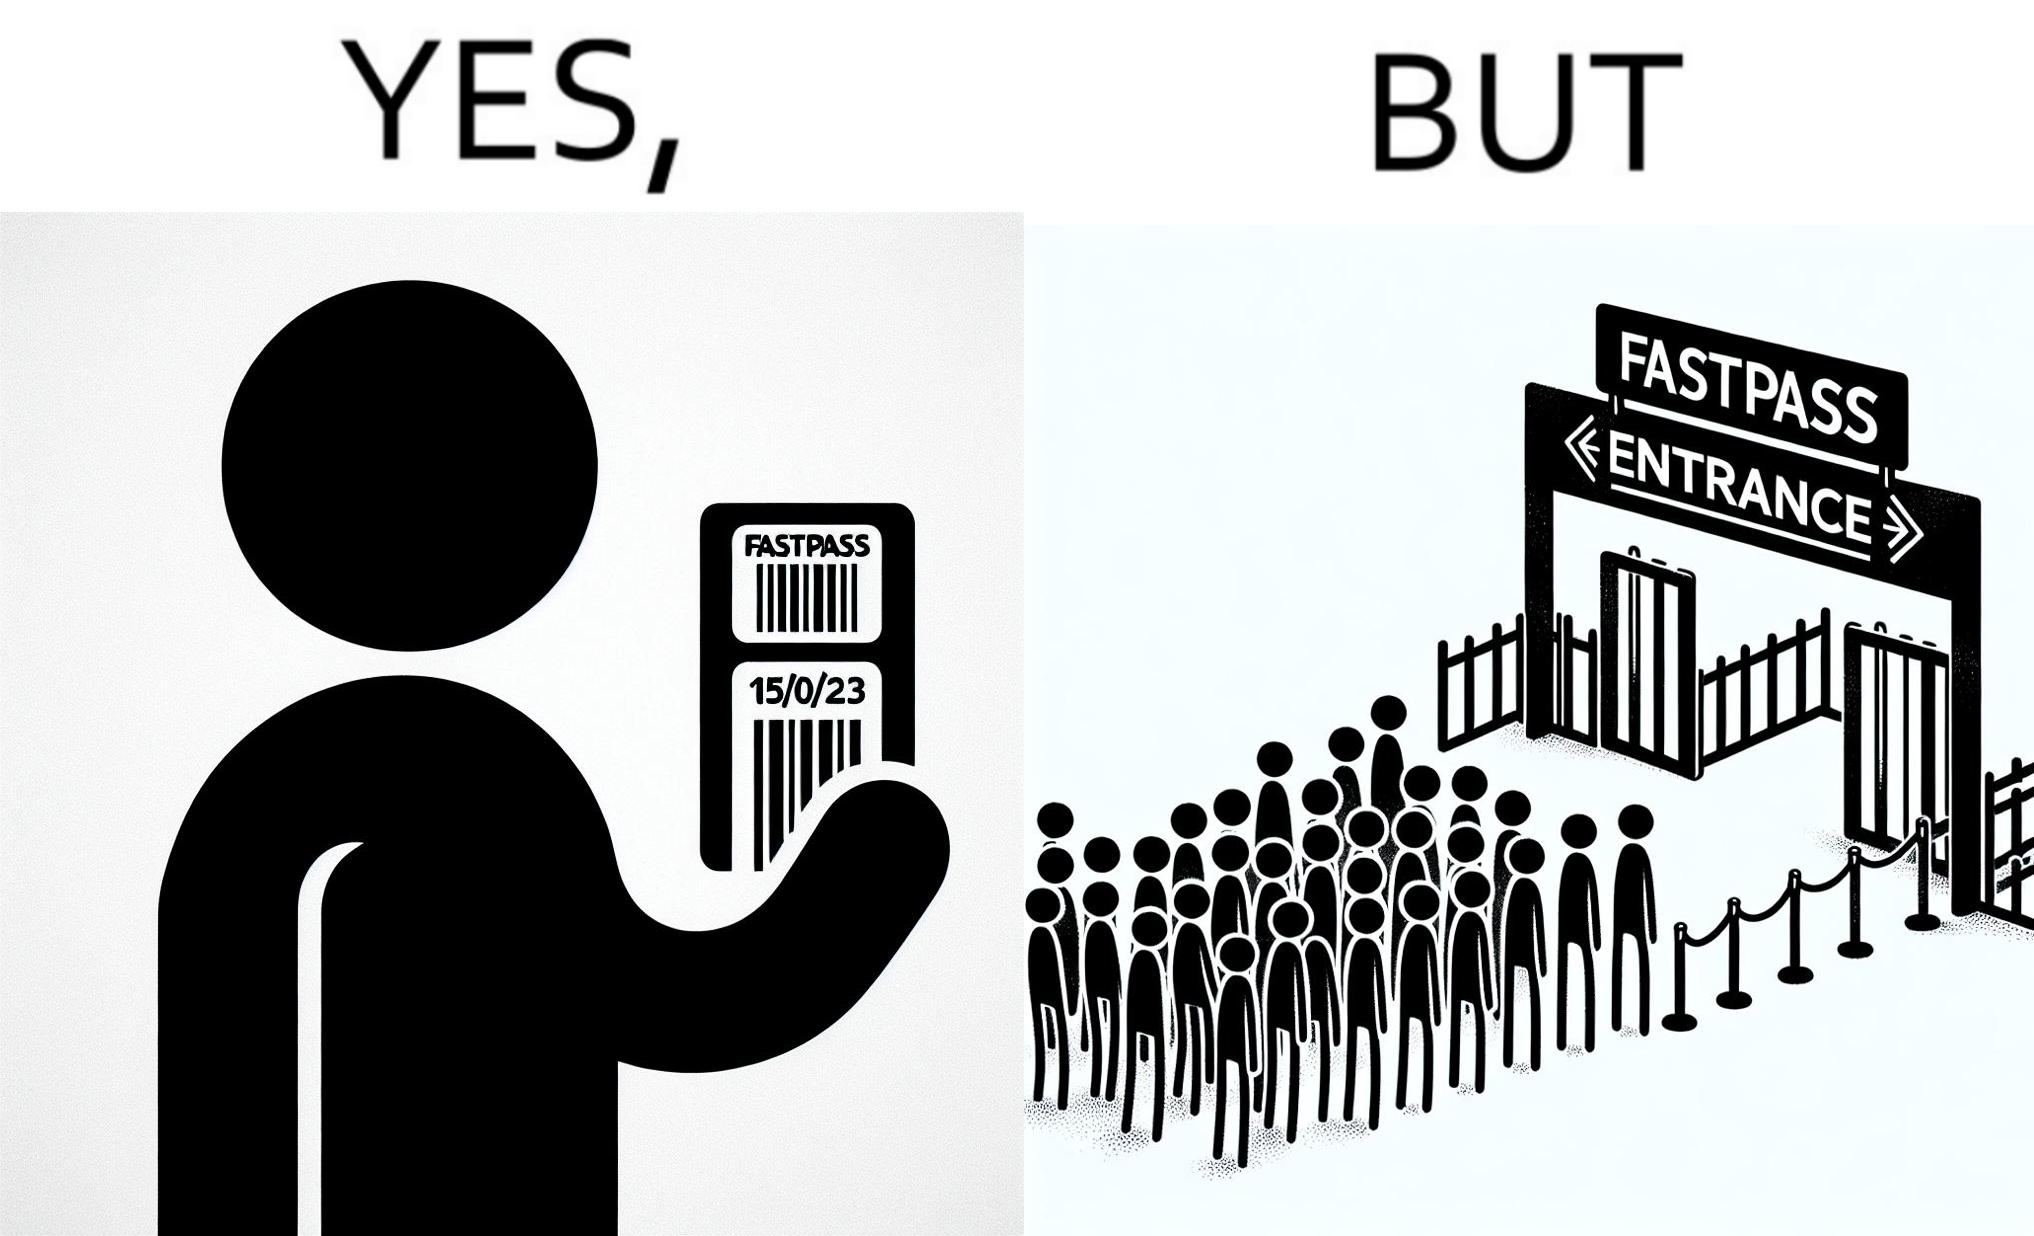Describe the satirical element in this image. The image is ironic, because fast pass entrance was meant for people to pass the gate fast but as more no. of people bought the pass due to which the queue has become longer and it becomes slow and time consuming 